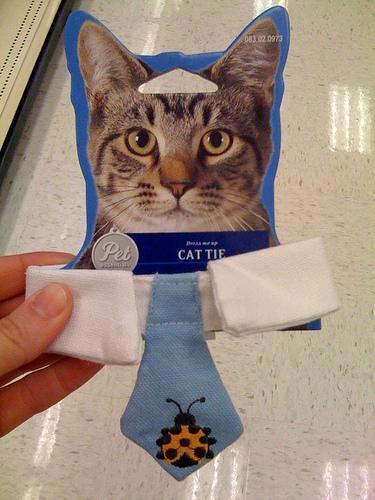How many cars in the picture are on the road?
Give a very brief answer. 0. 